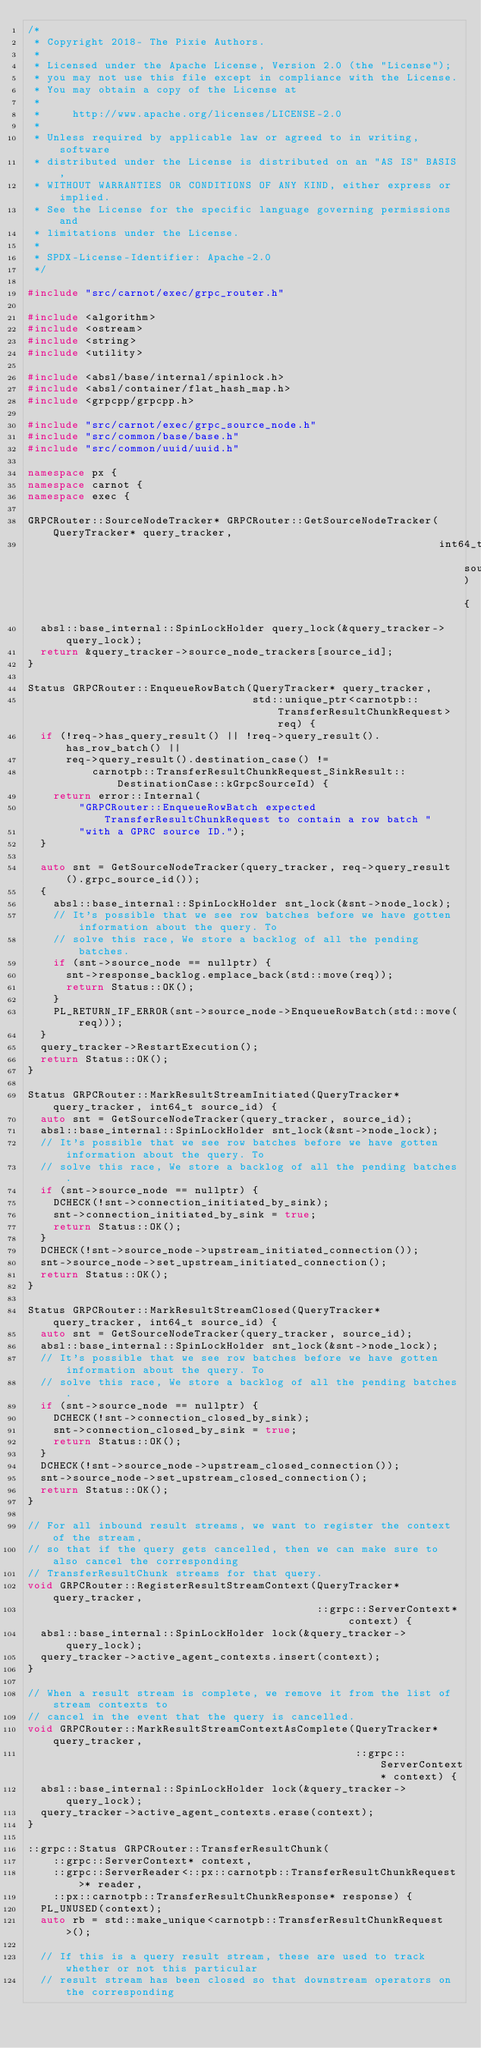<code> <loc_0><loc_0><loc_500><loc_500><_C++_>/*
 * Copyright 2018- The Pixie Authors.
 *
 * Licensed under the Apache License, Version 2.0 (the "License");
 * you may not use this file except in compliance with the License.
 * You may obtain a copy of the License at
 *
 *     http://www.apache.org/licenses/LICENSE-2.0
 *
 * Unless required by applicable law or agreed to in writing, software
 * distributed under the License is distributed on an "AS IS" BASIS,
 * WITHOUT WARRANTIES OR CONDITIONS OF ANY KIND, either express or implied.
 * See the License for the specific language governing permissions and
 * limitations under the License.
 *
 * SPDX-License-Identifier: Apache-2.0
 */

#include "src/carnot/exec/grpc_router.h"

#include <algorithm>
#include <ostream>
#include <string>
#include <utility>

#include <absl/base/internal/spinlock.h>
#include <absl/container/flat_hash_map.h>
#include <grpcpp/grpcpp.h>

#include "src/carnot/exec/grpc_source_node.h"
#include "src/common/base/base.h"
#include "src/common/uuid/uuid.h"

namespace px {
namespace carnot {
namespace exec {

GRPCRouter::SourceNodeTracker* GRPCRouter::GetSourceNodeTracker(QueryTracker* query_tracker,
                                                                int64_t source_id) {
  absl::base_internal::SpinLockHolder query_lock(&query_tracker->query_lock);
  return &query_tracker->source_node_trackers[source_id];
}

Status GRPCRouter::EnqueueRowBatch(QueryTracker* query_tracker,
                                   std::unique_ptr<carnotpb::TransferResultChunkRequest> req) {
  if (!req->has_query_result() || !req->query_result().has_row_batch() ||
      req->query_result().destination_case() !=
          carnotpb::TransferResultChunkRequest_SinkResult::DestinationCase::kGrpcSourceId) {
    return error::Internal(
        "GRPCRouter::EnqueueRowBatch expected TransferResultChunkRequest to contain a row batch "
        "with a GPRC source ID.");
  }

  auto snt = GetSourceNodeTracker(query_tracker, req->query_result().grpc_source_id());
  {
    absl::base_internal::SpinLockHolder snt_lock(&snt->node_lock);
    // It's possible that we see row batches before we have gotten information about the query. To
    // solve this race, We store a backlog of all the pending batches.
    if (snt->source_node == nullptr) {
      snt->response_backlog.emplace_back(std::move(req));
      return Status::OK();
    }
    PL_RETURN_IF_ERROR(snt->source_node->EnqueueRowBatch(std::move(req)));
  }
  query_tracker->RestartExecution();
  return Status::OK();
}

Status GRPCRouter::MarkResultStreamInitiated(QueryTracker* query_tracker, int64_t source_id) {
  auto snt = GetSourceNodeTracker(query_tracker, source_id);
  absl::base_internal::SpinLockHolder snt_lock(&snt->node_lock);
  // It's possible that we see row batches before we have gotten information about the query. To
  // solve this race, We store a backlog of all the pending batches.
  if (snt->source_node == nullptr) {
    DCHECK(!snt->connection_initiated_by_sink);
    snt->connection_initiated_by_sink = true;
    return Status::OK();
  }
  DCHECK(!snt->source_node->upstream_initiated_connection());
  snt->source_node->set_upstream_initiated_connection();
  return Status::OK();
}

Status GRPCRouter::MarkResultStreamClosed(QueryTracker* query_tracker, int64_t source_id) {
  auto snt = GetSourceNodeTracker(query_tracker, source_id);
  absl::base_internal::SpinLockHolder snt_lock(&snt->node_lock);
  // It's possible that we see row batches before we have gotten information about the query. To
  // solve this race, We store a backlog of all the pending batches.
  if (snt->source_node == nullptr) {
    DCHECK(!snt->connection_closed_by_sink);
    snt->connection_closed_by_sink = true;
    return Status::OK();
  }
  DCHECK(!snt->source_node->upstream_closed_connection());
  snt->source_node->set_upstream_closed_connection();
  return Status::OK();
}

// For all inbound result streams, we want to register the context of the stream,
// so that if the query gets cancelled, then we can make sure to also cancel the corresponding
// TransferResultChunk streams for that query.
void GRPCRouter::RegisterResultStreamContext(QueryTracker* query_tracker,
                                             ::grpc::ServerContext* context) {
  absl::base_internal::SpinLockHolder lock(&query_tracker->query_lock);
  query_tracker->active_agent_contexts.insert(context);
}

// When a result stream is complete, we remove it from the list of stream contexts to
// cancel in the event that the query is cancelled.
void GRPCRouter::MarkResultStreamContextAsComplete(QueryTracker* query_tracker,
                                                   ::grpc::ServerContext* context) {
  absl::base_internal::SpinLockHolder lock(&query_tracker->query_lock);
  query_tracker->active_agent_contexts.erase(context);
}

::grpc::Status GRPCRouter::TransferResultChunk(
    ::grpc::ServerContext* context,
    ::grpc::ServerReader<::px::carnotpb::TransferResultChunkRequest>* reader,
    ::px::carnotpb::TransferResultChunkResponse* response) {
  PL_UNUSED(context);
  auto rb = std::make_unique<carnotpb::TransferResultChunkRequest>();

  // If this is a query result stream, these are used to track whether or not this particular
  // result stream has been closed so that downstream operators on the corresponding</code> 